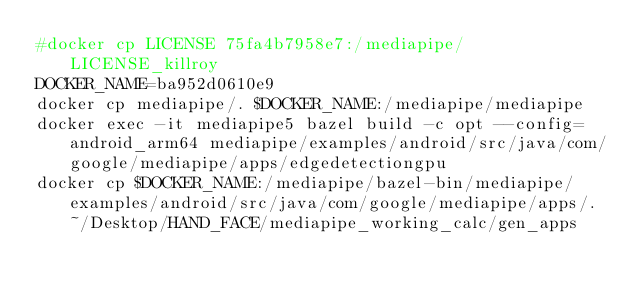<code> <loc_0><loc_0><loc_500><loc_500><_Bash_>#docker cp LICENSE 75fa4b7958e7:/mediapipe/LICENSE_killroy
DOCKER_NAME=ba952d0610e9
docker cp mediapipe/. $DOCKER_NAME:/mediapipe/mediapipe
docker exec -it mediapipe5 bazel build -c opt --config=android_arm64 mediapipe/examples/android/src/java/com/google/mediapipe/apps/edgedetectiongpu
docker cp $DOCKER_NAME:/mediapipe/bazel-bin/mediapipe/examples/android/src/java/com/google/mediapipe/apps/. ~/Desktop/HAND_FACE/mediapipe_working_calc/gen_apps</code> 